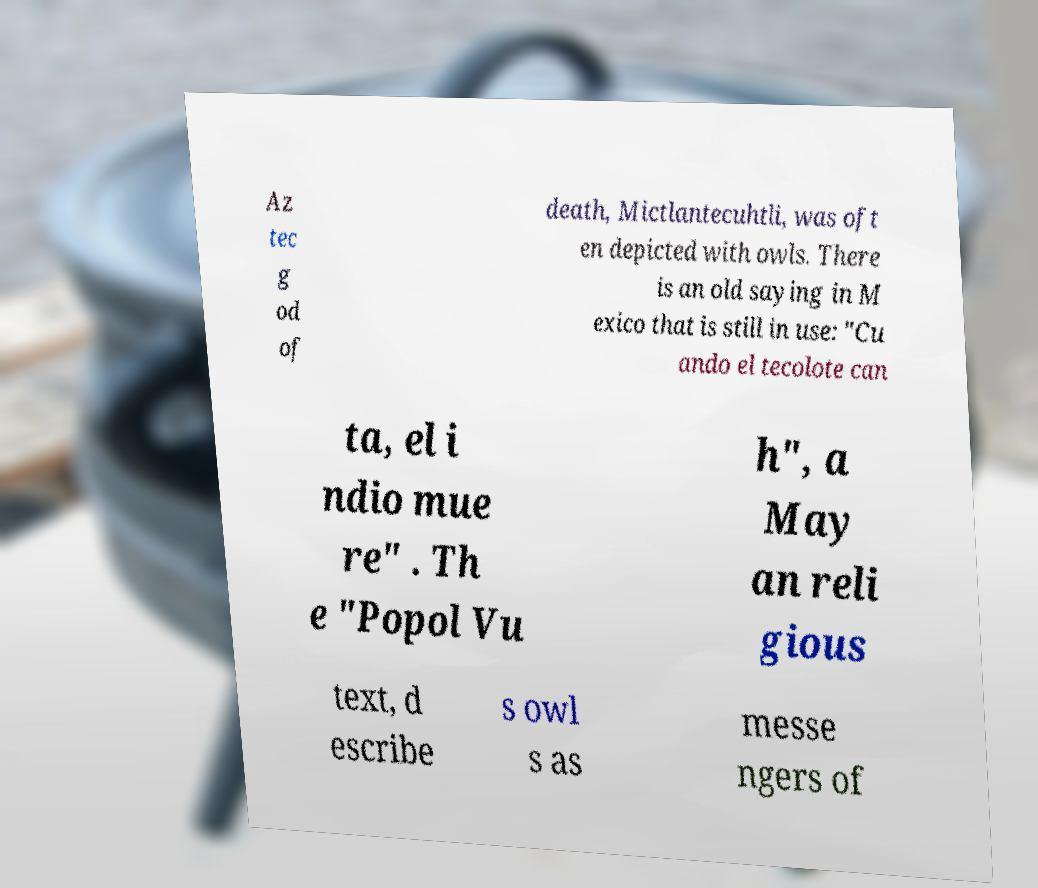For documentation purposes, I need the text within this image transcribed. Could you provide that? Az tec g od of death, Mictlantecuhtli, was oft en depicted with owls. There is an old saying in M exico that is still in use: "Cu ando el tecolote can ta, el i ndio mue re" . Th e "Popol Vu h", a May an reli gious text, d escribe s owl s as messe ngers of 